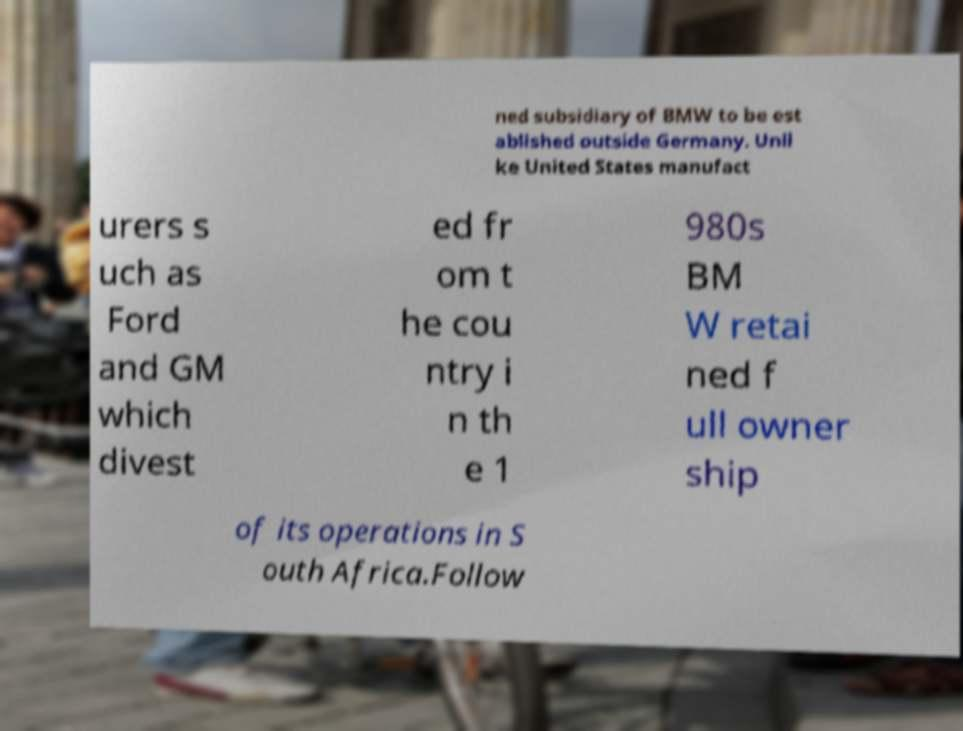Could you assist in decoding the text presented in this image and type it out clearly? ned subsidiary of BMW to be est ablished outside Germany. Unli ke United States manufact urers s uch as Ford and GM which divest ed fr om t he cou ntry i n th e 1 980s BM W retai ned f ull owner ship of its operations in S outh Africa.Follow 